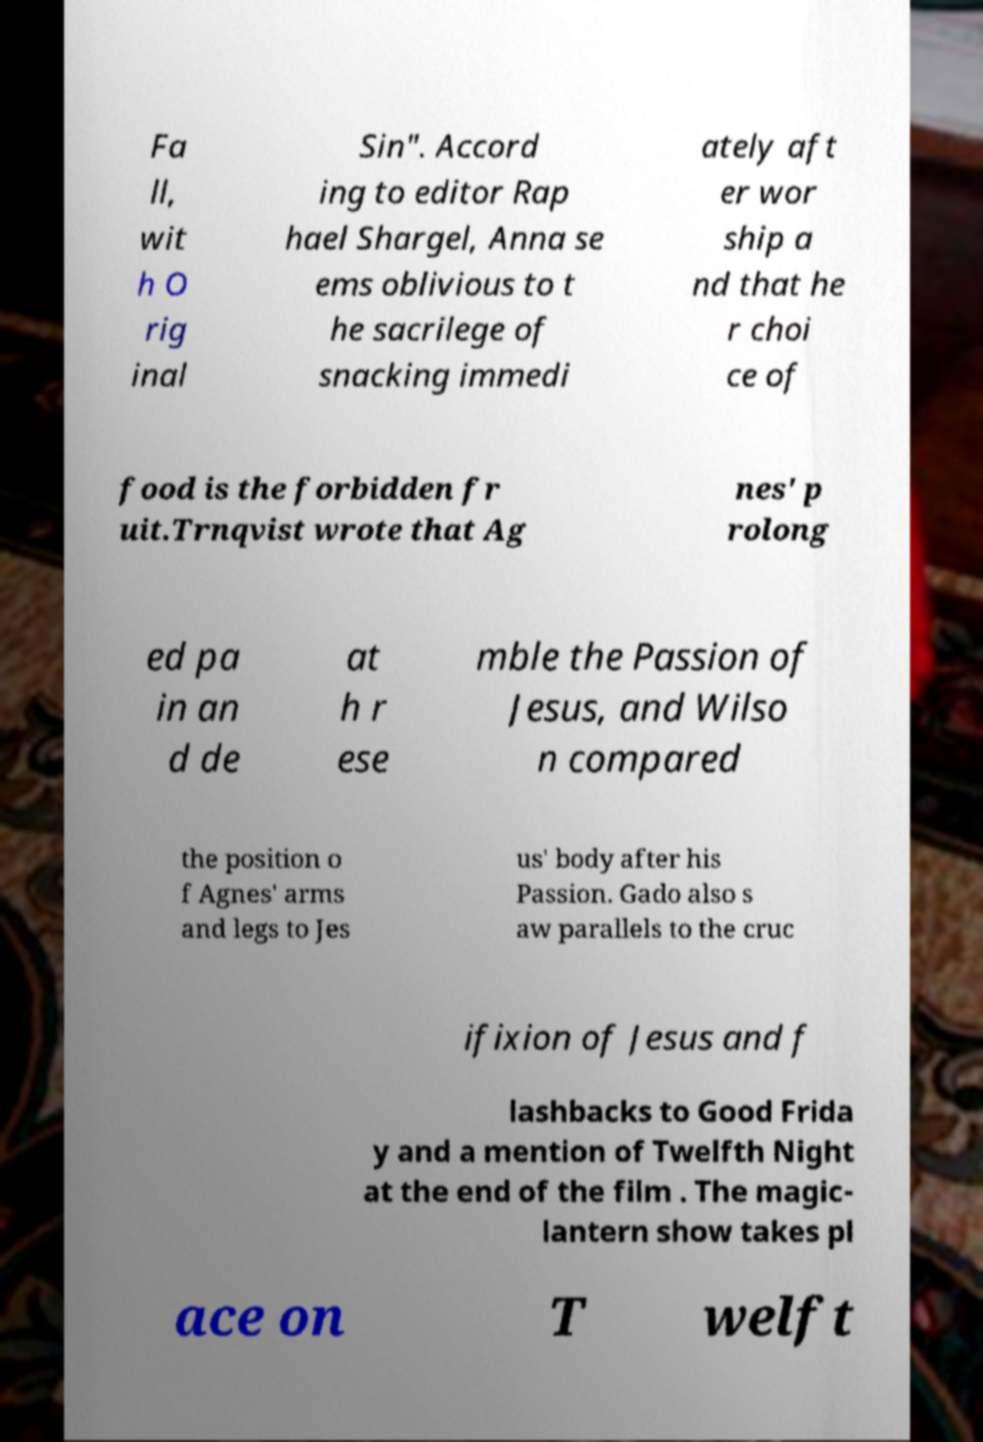For documentation purposes, I need the text within this image transcribed. Could you provide that? Fa ll, wit h O rig inal Sin". Accord ing to editor Rap hael Shargel, Anna se ems oblivious to t he sacrilege of snacking immedi ately aft er wor ship a nd that he r choi ce of food is the forbidden fr uit.Trnqvist wrote that Ag nes' p rolong ed pa in an d de at h r ese mble the Passion of Jesus, and Wilso n compared the position o f Agnes' arms and legs to Jes us' body after his Passion. Gado also s aw parallels to the cruc ifixion of Jesus and f lashbacks to Good Frida y and a mention of Twelfth Night at the end of the film . The magic- lantern show takes pl ace on T welft 